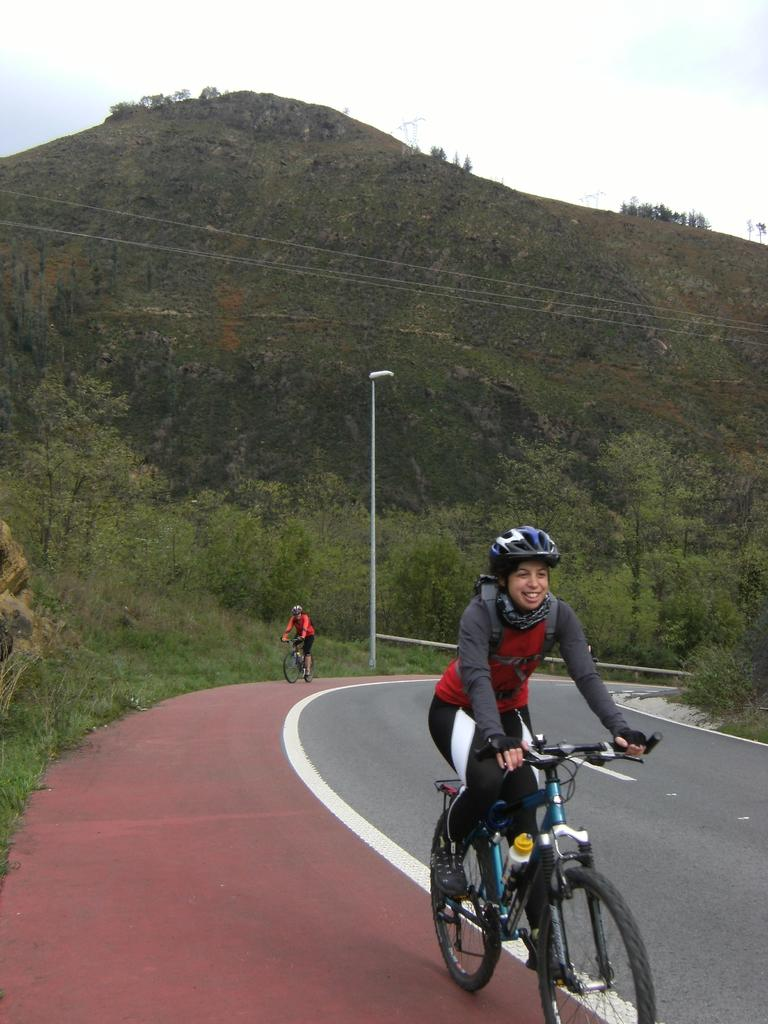What are the persons in the image doing? The persons in the image are cycling. Where are the cyclists located? The cyclists are on a road. What can be seen in the background of the image? There is a pole, trees, a hill, and the sky visible in the background of the image. What type of writing can be seen on the band in the image? There is no band present in the image, so there is no writing to observe. 